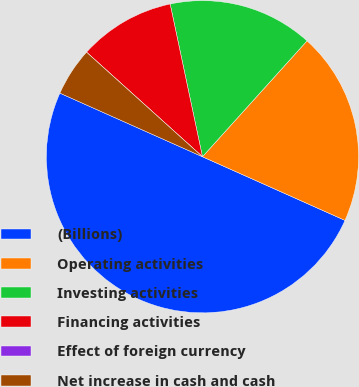<chart> <loc_0><loc_0><loc_500><loc_500><pie_chart><fcel>(Billions)<fcel>Operating activities<fcel>Investing activities<fcel>Financing activities<fcel>Effect of foreign currency<fcel>Net increase in cash and cash<nl><fcel>49.99%<fcel>20.0%<fcel>15.0%<fcel>10.0%<fcel>0.0%<fcel>5.0%<nl></chart> 